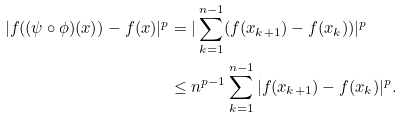<formula> <loc_0><loc_0><loc_500><loc_500>| f ( ( \psi \circ \phi ) ( x ) ) - f ( x ) | ^ { p } & = | \sum _ { k = 1 } ^ { n - 1 } ( f ( x _ { k + 1 } ) - f ( x _ { k } ) ) | ^ { p } \\ & \leq n ^ { p - 1 } \sum _ { k = 1 } ^ { n - 1 } | f ( x _ { k + 1 } ) - f ( x _ { k } ) | ^ { p } .</formula> 